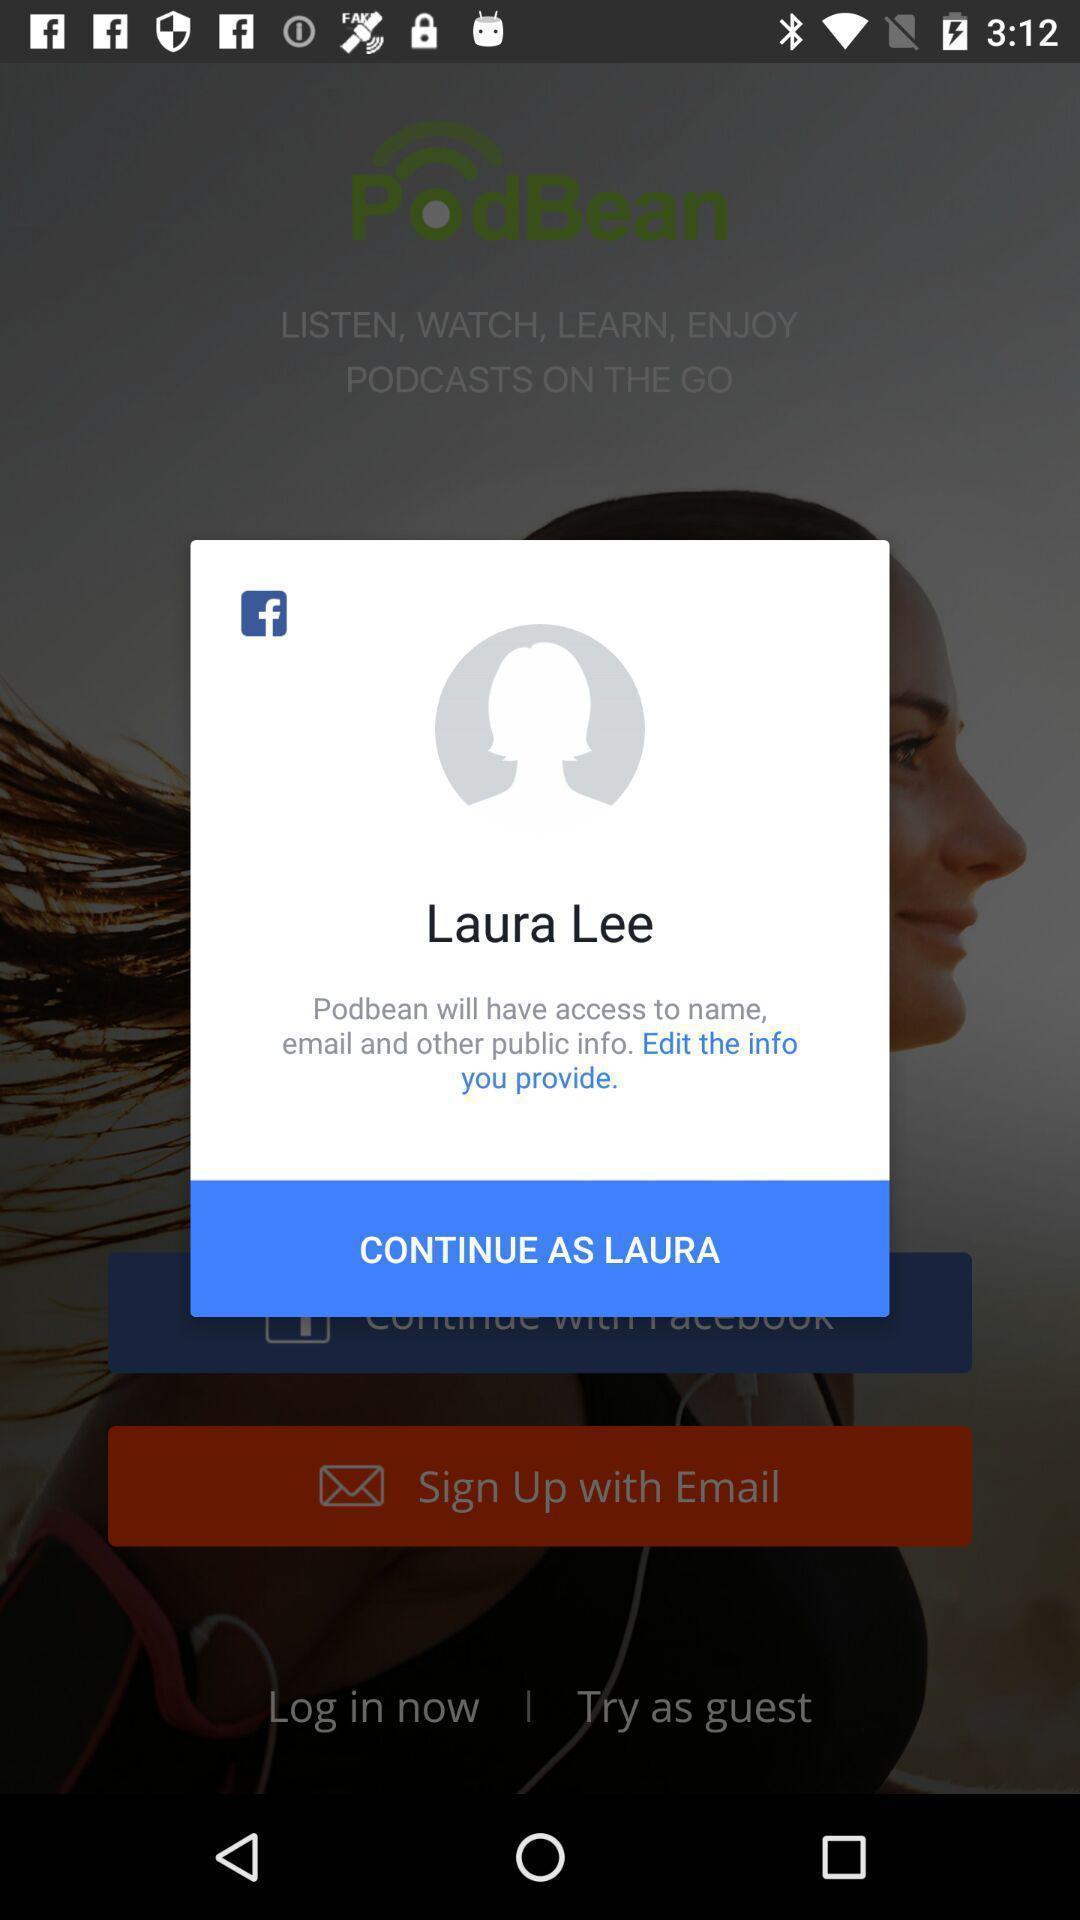Give me a summary of this screen capture. Pop-up showing profile continuation page of a social app. 